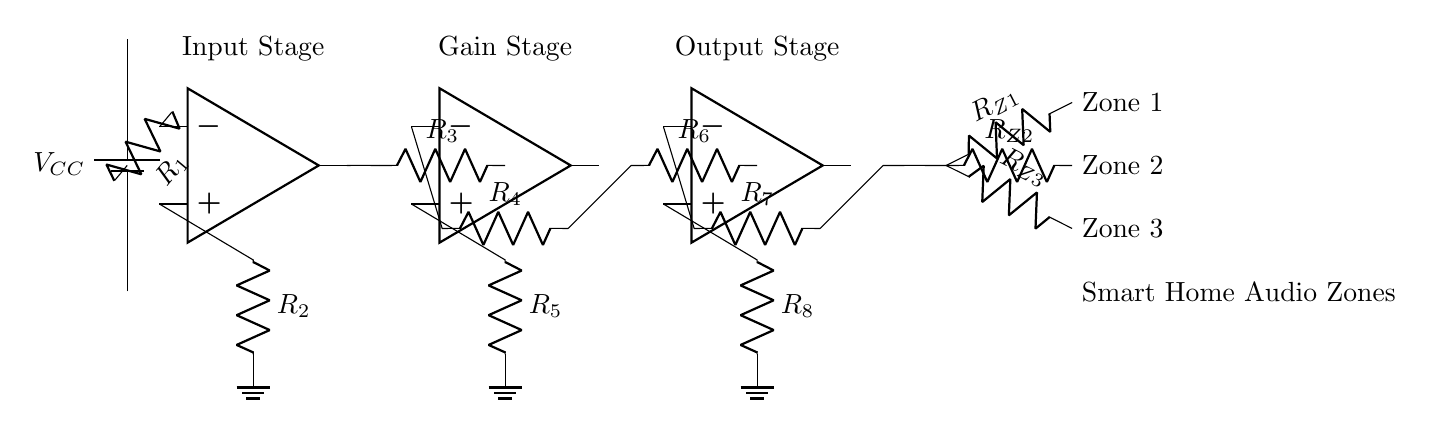What is the power supply voltage for this circuit? The power supply voltage is indicated as VCC on the circuit diagram, which represents the input voltage for the amplifier.
Answer: VCC How many operational amplifiers are in this circuit? There are three operational amplifiers indicated by the symbols labeled "op amp" in the diagram.
Answer: 3 What is the purpose of the resistors R1, R2, R3, R4, R5, R6, R7, and R8? These resistors are used in various stages (input, gain, output) of the amplifier to set the gain and adjust signal levels in the circuit according to the configurations needed for proper audio amplification.
Answer: Gain and signal adjustment Which components control audio zones in this circuit? The resistors labeled RZ1, RZ2, and RZ3 are connected to the output stage and are designated to control three separate audio zones.
Answer: RZ1, RZ2, RZ3 What is the function of the gain stage? The gain stage amplifies the signal received from the input stage to increase the overall audio output level before it reaches the output stage.
Answer: Signal amplification How are the audio zones connected to the amplifier? The audio zones are connected in a parallel configuration from the output of the amplifier, allowing each zone to receive an amplified audio signal independently.
Answer: Parallel configuration 